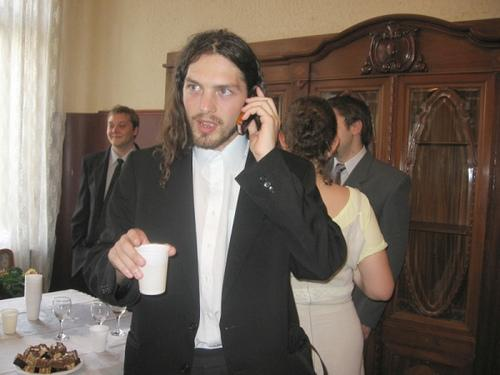What kind of telephone is being used? cellular 